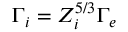<formula> <loc_0><loc_0><loc_500><loc_500>\Gamma _ { i } = Z _ { i } ^ { 5 / 3 } \Gamma _ { e }</formula> 